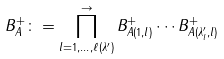<formula> <loc_0><loc_0><loc_500><loc_500>B _ { A } ^ { + } \colon = \prod _ { l = 1 , \dots , \ell ( \lambda ^ { \prime } ) } ^ { \rightarrow } B _ { A ( 1 , l ) } ^ { + } \cdots B _ { A ( \lambda _ { l } ^ { \prime } , l ) } ^ { + }</formula> 